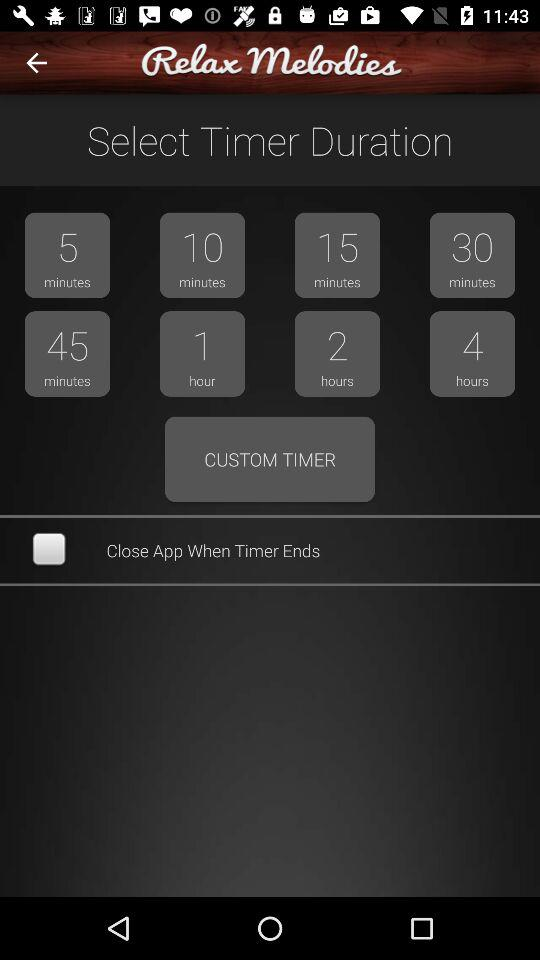What is the application name?
When the provided information is insufficient, respond with <no answer>. <no answer> 